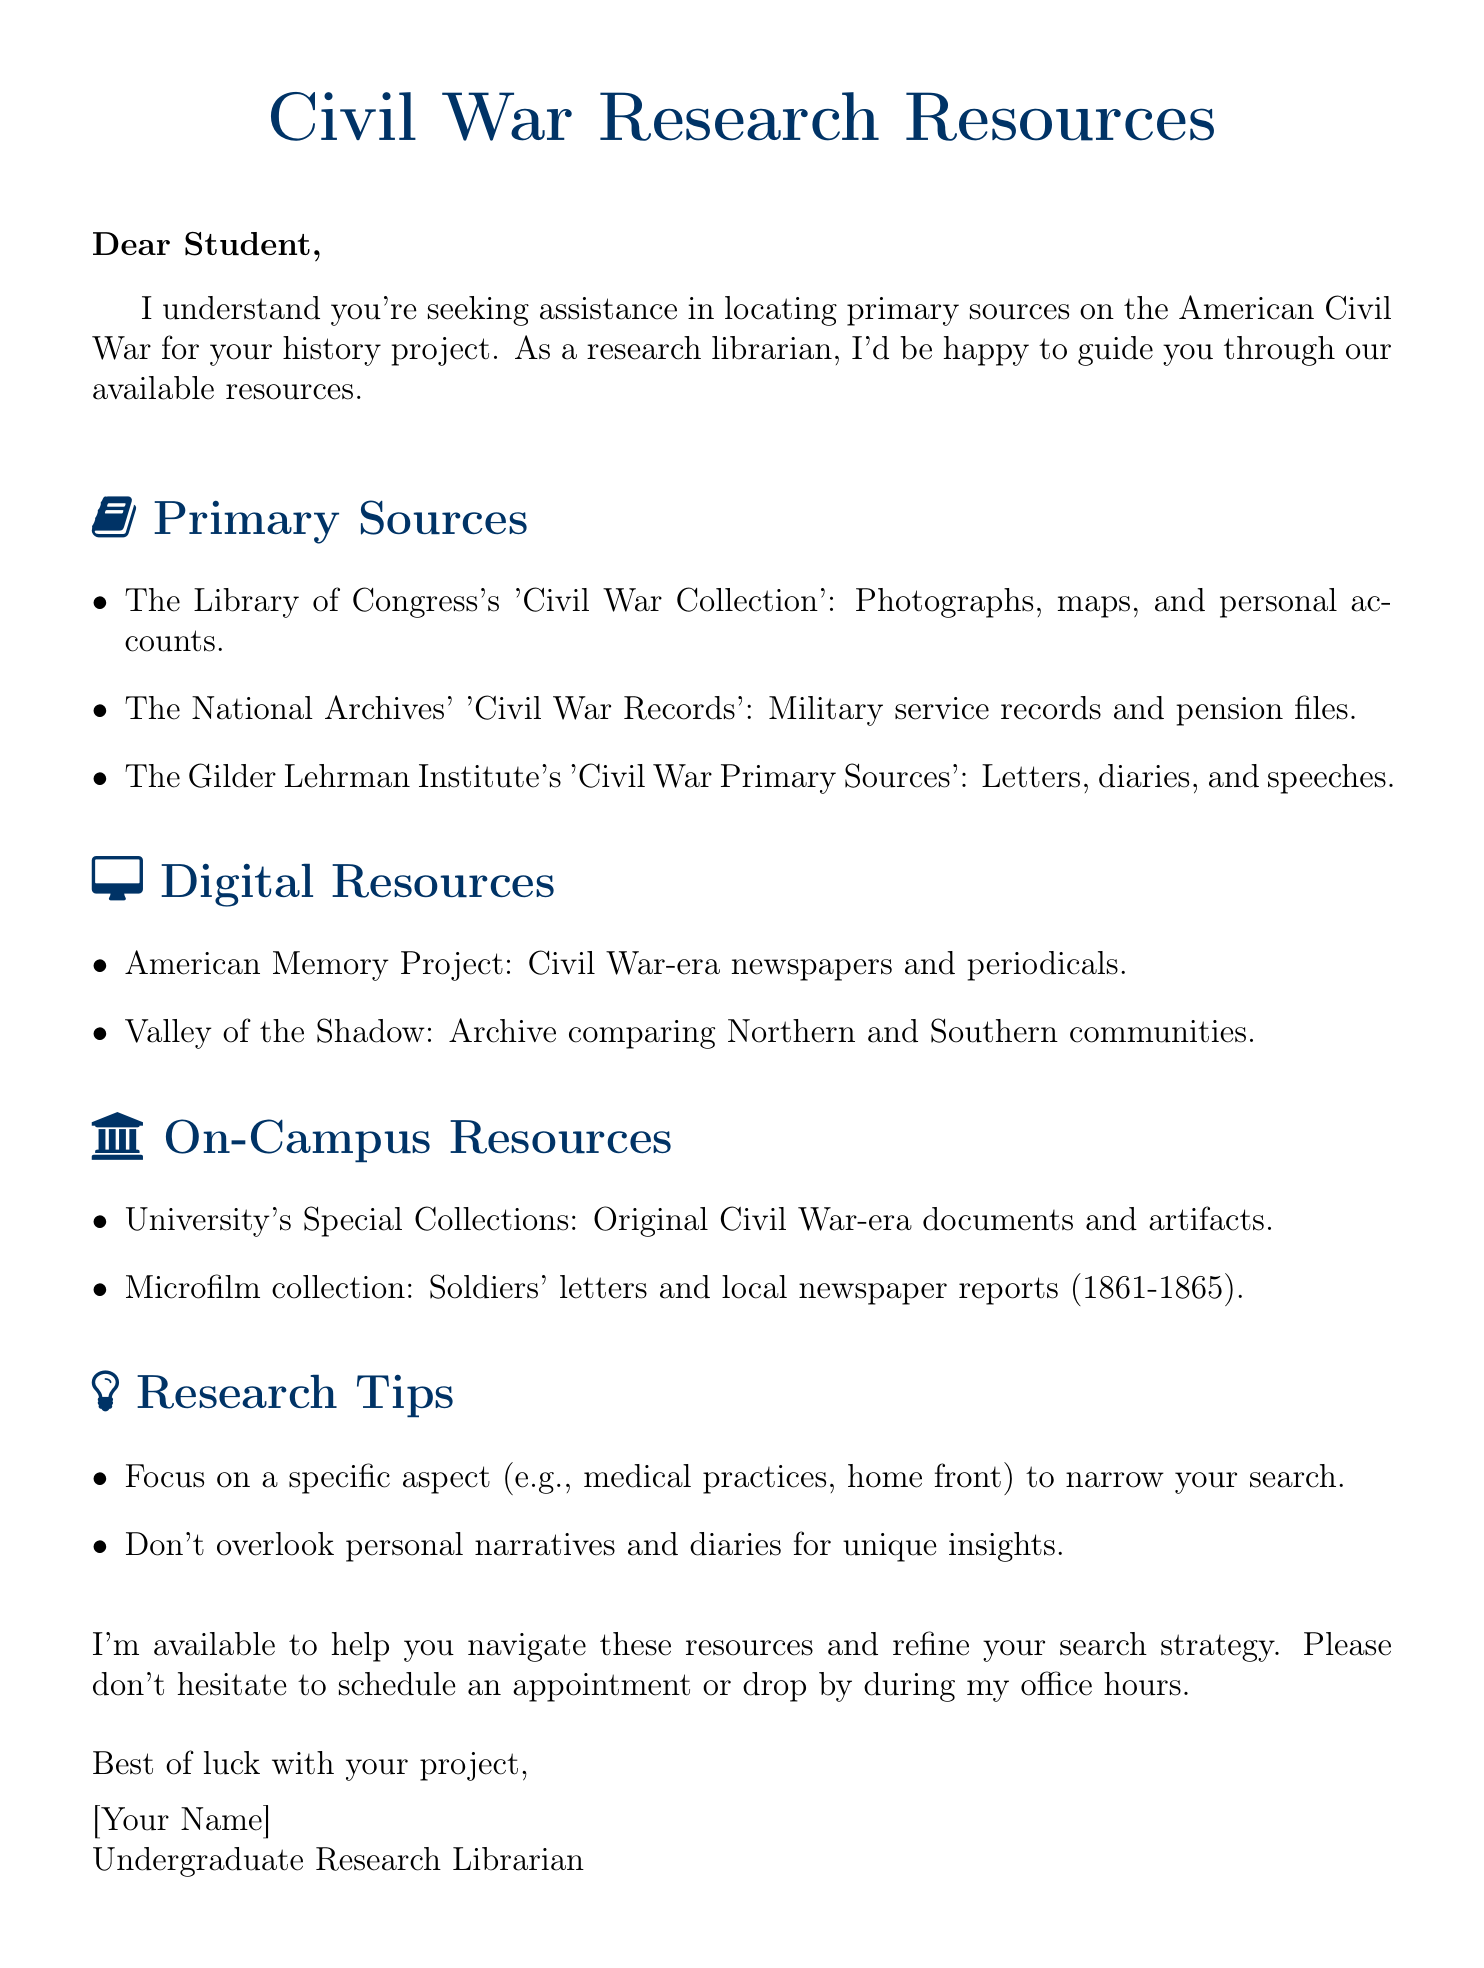What is the title of the document? The title is given in the center of the document, which is "Civil War Research Resources."
Answer: Civil War Research Resources How many primary sources are listed? The document lists three primary sources in the section about them.
Answer: 3 What type of resource is the American Memory Project? The American Memory Project is categorized under digital resources in the document.
Answer: Digital Resource Which organization has a collection that includes letters and diaries? The Gilder Lehrman Institute is mentioned to have a collection with letters and diaries.
Answer: Gilder Lehrman Institute What is a recommended research tip mentioned? One of the research tips suggests focusing on a specific aspect of the war for a more targeted search.
Answer: Focus on a specific aspect What are the names of the two digital resources mentioned? The document provides names of two digital resources: American Memory Project and Valley of the Shadow.
Answer: American Memory Project, Valley of the Shadow Who is offering assistance in the document? The document states that an Undergraduate Research Librarian is offering assistance.
Answer: Undergraduate Research Librarian What is located in the university's Special Collections? The university's Special Collections house original Civil War-era documents and artifacts.
Answer: Original Civil War-era documents and artifacts 